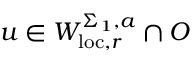<formula> <loc_0><loc_0><loc_500><loc_500>u \in W _ { l o c , r } ^ { \Sigma _ { 1 } , a } \cap O</formula> 